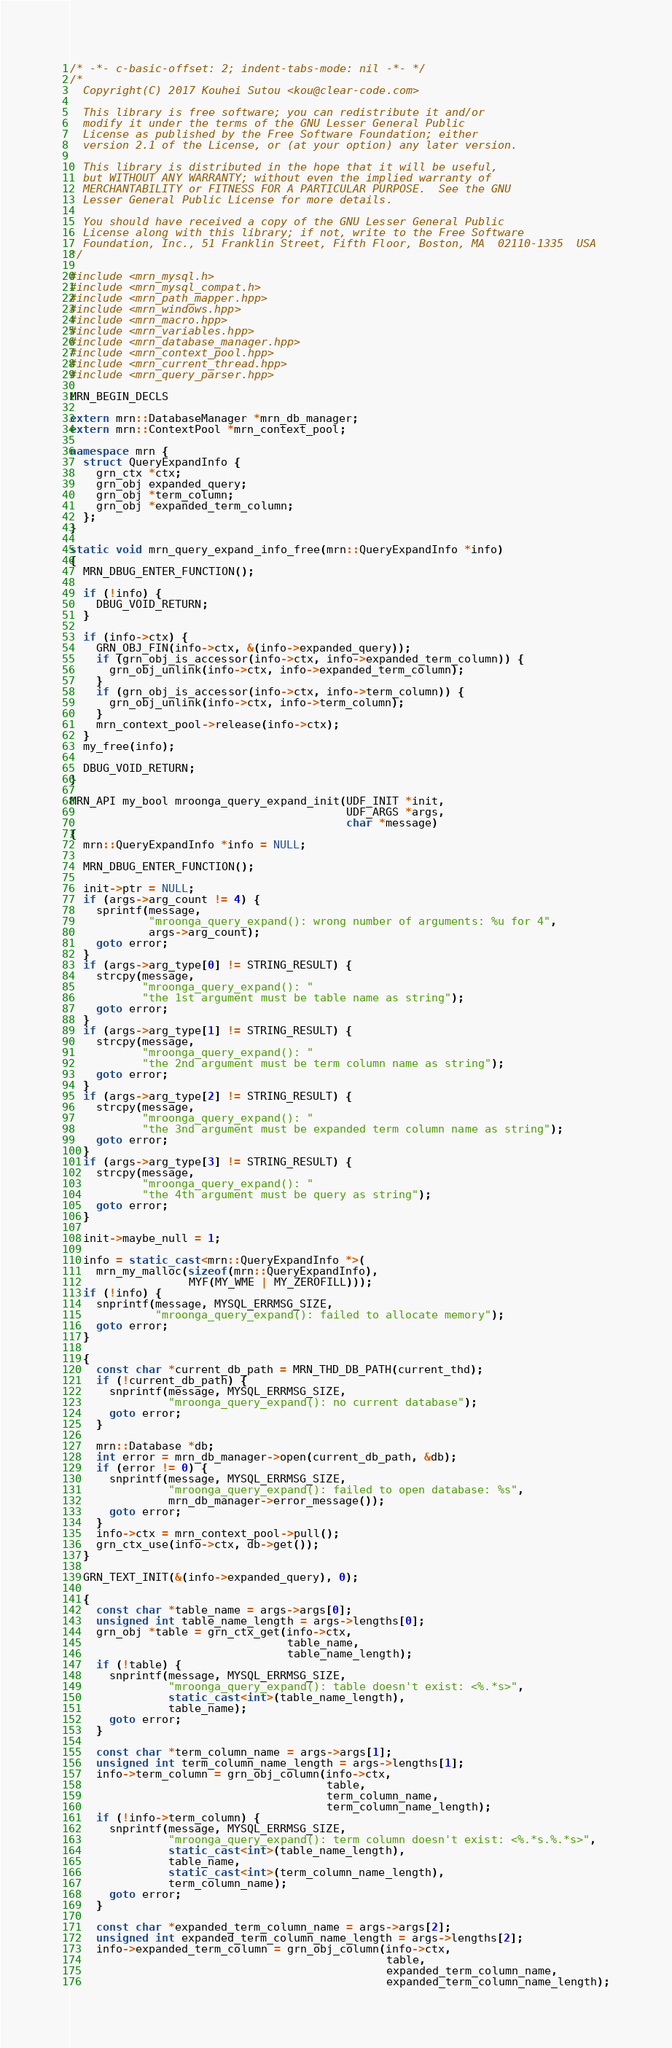<code> <loc_0><loc_0><loc_500><loc_500><_C++_>/* -*- c-basic-offset: 2; indent-tabs-mode: nil -*- */
/*
  Copyright(C) 2017 Kouhei Sutou <kou@clear-code.com>

  This library is free software; you can redistribute it and/or
  modify it under the terms of the GNU Lesser General Public
  License as published by the Free Software Foundation; either
  version 2.1 of the License, or (at your option) any later version.

  This library is distributed in the hope that it will be useful,
  but WITHOUT ANY WARRANTY; without even the implied warranty of
  MERCHANTABILITY or FITNESS FOR A PARTICULAR PURPOSE.  See the GNU
  Lesser General Public License for more details.

  You should have received a copy of the GNU Lesser General Public
  License along with this library; if not, write to the Free Software
  Foundation, Inc., 51 Franklin Street, Fifth Floor, Boston, MA  02110-1335  USA
*/

#include <mrn_mysql.h>
#include <mrn_mysql_compat.h>
#include <mrn_path_mapper.hpp>
#include <mrn_windows.hpp>
#include <mrn_macro.hpp>
#include <mrn_variables.hpp>
#include <mrn_database_manager.hpp>
#include <mrn_context_pool.hpp>
#include <mrn_current_thread.hpp>
#include <mrn_query_parser.hpp>

MRN_BEGIN_DECLS

extern mrn::DatabaseManager *mrn_db_manager;
extern mrn::ContextPool *mrn_context_pool;

namespace mrn {
  struct QueryExpandInfo {
    grn_ctx *ctx;
    grn_obj expanded_query;
    grn_obj *term_column;
    grn_obj *expanded_term_column;
  };
}

static void mrn_query_expand_info_free(mrn::QueryExpandInfo *info)
{
  MRN_DBUG_ENTER_FUNCTION();

  if (!info) {
    DBUG_VOID_RETURN;
  }

  if (info->ctx) {
    GRN_OBJ_FIN(info->ctx, &(info->expanded_query));
    if (grn_obj_is_accessor(info->ctx, info->expanded_term_column)) {
      grn_obj_unlink(info->ctx, info->expanded_term_column);
    }
    if (grn_obj_is_accessor(info->ctx, info->term_column)) {
      grn_obj_unlink(info->ctx, info->term_column);
    }
    mrn_context_pool->release(info->ctx);
  }
  my_free(info);

  DBUG_VOID_RETURN;
}

MRN_API my_bool mroonga_query_expand_init(UDF_INIT *init,
                                          UDF_ARGS *args,
                                          char *message)
{
  mrn::QueryExpandInfo *info = NULL;

  MRN_DBUG_ENTER_FUNCTION();

  init->ptr = NULL;
  if (args->arg_count != 4) {
    sprintf(message,
            "mroonga_query_expand(): wrong number of arguments: %u for 4",
            args->arg_count);
    goto error;
  }
  if (args->arg_type[0] != STRING_RESULT) {
    strcpy(message,
           "mroonga_query_expand(): "
           "the 1st argument must be table name as string");
    goto error;
  }
  if (args->arg_type[1] != STRING_RESULT) {
    strcpy(message,
           "mroonga_query_expand(): "
           "the 2nd argument must be term column name as string");
    goto error;
  }
  if (args->arg_type[2] != STRING_RESULT) {
    strcpy(message,
           "mroonga_query_expand(): "
           "the 3nd argument must be expanded term column name as string");
    goto error;
  }
  if (args->arg_type[3] != STRING_RESULT) {
    strcpy(message,
           "mroonga_query_expand(): "
           "the 4th argument must be query as string");
    goto error;
  }

  init->maybe_null = 1;

  info = static_cast<mrn::QueryExpandInfo *>(
    mrn_my_malloc(sizeof(mrn::QueryExpandInfo),
                  MYF(MY_WME | MY_ZEROFILL)));
  if (!info) {
    snprintf(message, MYSQL_ERRMSG_SIZE,
             "mroonga_query_expand(): failed to allocate memory");
    goto error;
  }

  {
    const char *current_db_path = MRN_THD_DB_PATH(current_thd);
    if (!current_db_path) {
      snprintf(message, MYSQL_ERRMSG_SIZE,
               "mroonga_query_expand(): no current database");
      goto error;
    }

    mrn::Database *db;
    int error = mrn_db_manager->open(current_db_path, &db);
    if (error != 0) {
      snprintf(message, MYSQL_ERRMSG_SIZE,
               "mroonga_query_expand(): failed to open database: %s",
               mrn_db_manager->error_message());
      goto error;
    }
    info->ctx = mrn_context_pool->pull();
    grn_ctx_use(info->ctx, db->get());
  }

  GRN_TEXT_INIT(&(info->expanded_query), 0);

  {
    const char *table_name = args->args[0];
    unsigned int table_name_length = args->lengths[0];
    grn_obj *table = grn_ctx_get(info->ctx,
                                 table_name,
                                 table_name_length);
    if (!table) {
      snprintf(message, MYSQL_ERRMSG_SIZE,
               "mroonga_query_expand(): table doesn't exist: <%.*s>",
               static_cast<int>(table_name_length),
               table_name);
      goto error;
    }

    const char *term_column_name = args->args[1];
    unsigned int term_column_name_length = args->lengths[1];
    info->term_column = grn_obj_column(info->ctx,
                                       table,
                                       term_column_name,
                                       term_column_name_length);
    if (!info->term_column) {
      snprintf(message, MYSQL_ERRMSG_SIZE,
               "mroonga_query_expand(): term column doesn't exist: <%.*s.%.*s>",
               static_cast<int>(table_name_length),
               table_name,
               static_cast<int>(term_column_name_length),
               term_column_name);
      goto error;
    }

    const char *expanded_term_column_name = args->args[2];
    unsigned int expanded_term_column_name_length = args->lengths[2];
    info->expanded_term_column = grn_obj_column(info->ctx,
                                                table,
                                                expanded_term_column_name,
                                                expanded_term_column_name_length);</code> 